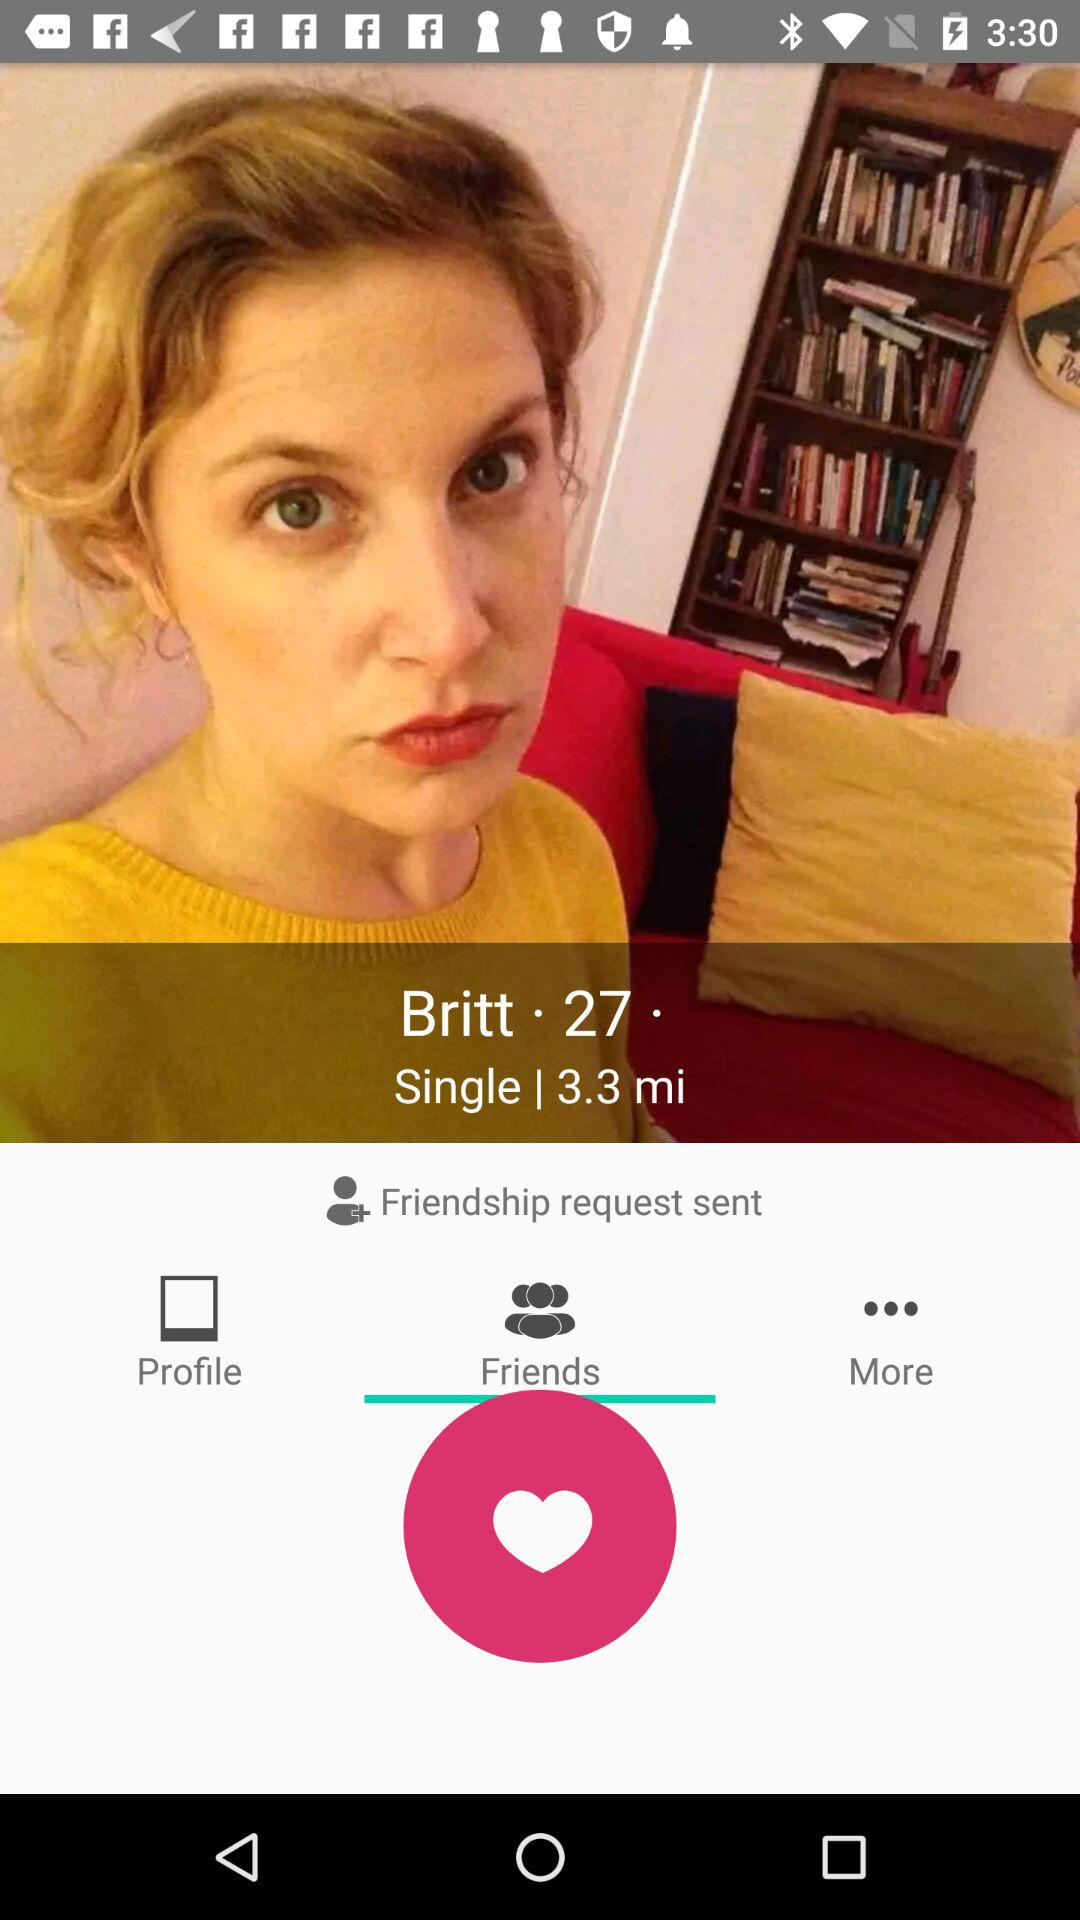Which tab is selected? The selected tab is "Friends". 